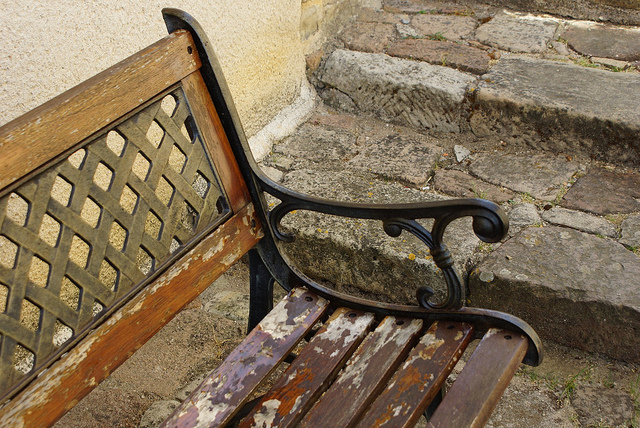What could be the historical significance or style of this bench? The bench features classic design elements, such as the ornate metal armrests and supports, which could indicate that it is an older piece. Such designs are often seen in traditional, Victorian-style furnishings, suggesting it might have historical value or be a reproduction styled to evoke a bygone era. 